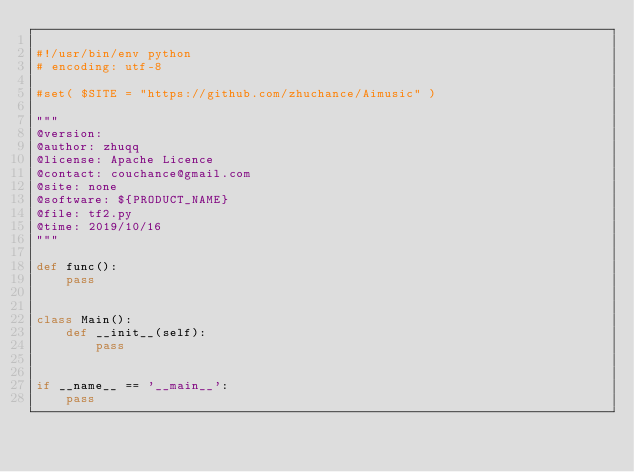Convert code to text. <code><loc_0><loc_0><loc_500><loc_500><_Python_>
#!/usr/bin/env python
# encoding: utf-8

#set( $SITE = "https://github.com/zhuchance/Aimusic" )

"""
@version: 
@author: zhuqq
@license: Apache Licence 
@contact: couchance@gmail.com
@site: none
@software: ${PRODUCT_NAME}
@file: tf2.py
@time: 2019/10/16
"""

def func():
    pass


class Main():
    def __init__(self):
        pass


if __name__ == '__main__':
    pass</code> 